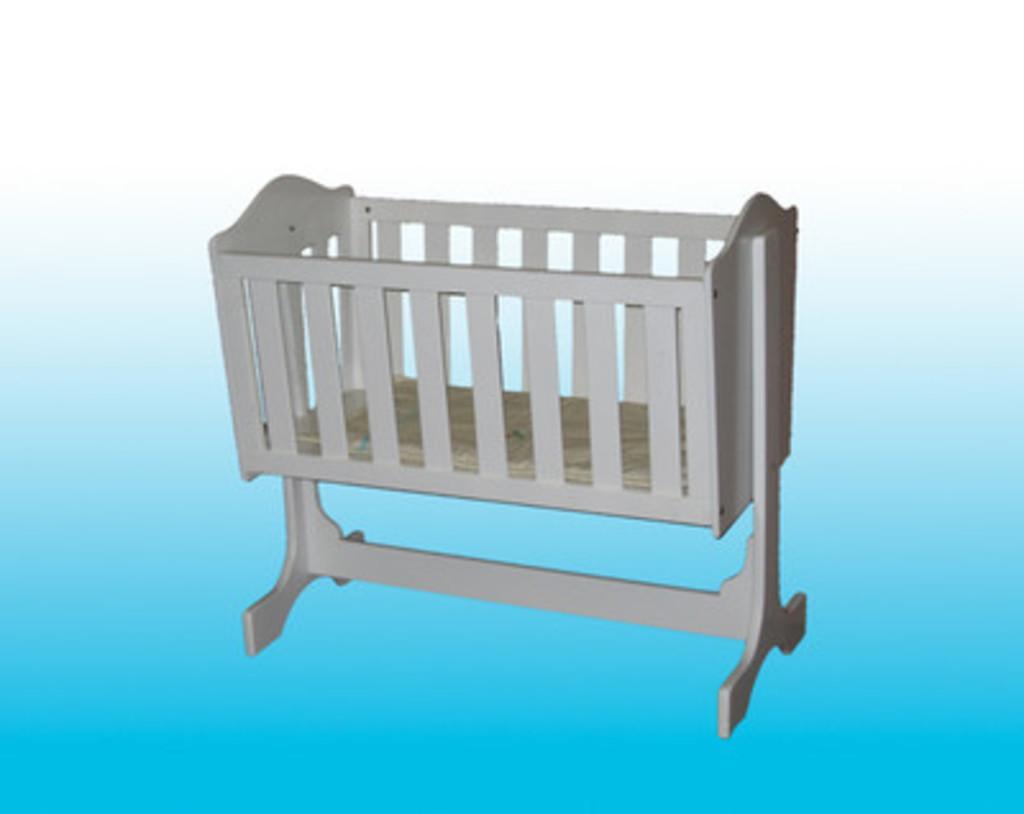In one or two sentences, can you explain what this image depicts? In this picture we can see a cradle here. 